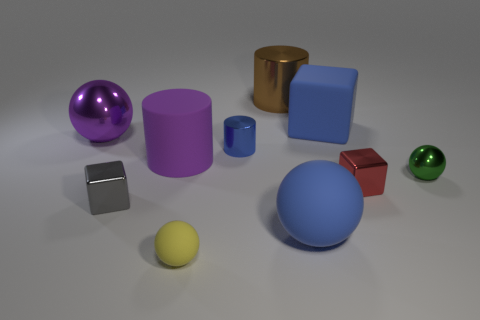Subtract 1 spheres. How many spheres are left? 3 Subtract all purple spheres. How many spheres are left? 3 Subtract all tiny yellow rubber spheres. How many spheres are left? 3 Subtract all gray spheres. Subtract all blue blocks. How many spheres are left? 4 Subtract all blocks. How many objects are left? 7 Subtract all small shiny cylinders. Subtract all tiny blue cylinders. How many objects are left? 8 Add 3 rubber blocks. How many rubber blocks are left? 4 Add 2 matte objects. How many matte objects exist? 6 Subtract 1 purple cylinders. How many objects are left? 9 